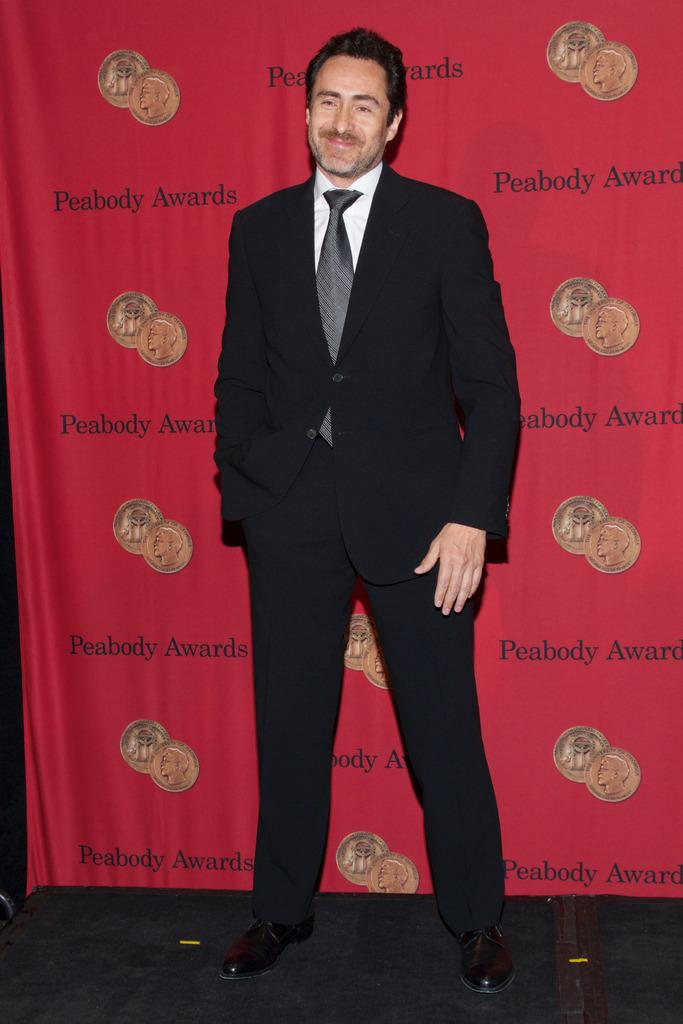What is the main subject of the image? The main subject of the image is a man standing in the image. Where is the man standing in the image? The man is standing on the floor in the image. What is the man's facial expression in the image? The man is smiling in the image. What can be seen in the background of the image? There is a banner in the background of the image. What type of field can be seen in the image? There is no field present in the image. What kind of roll is being used by the man in the image? There is no roll visible in the image; the man is simply standing and smiling. 